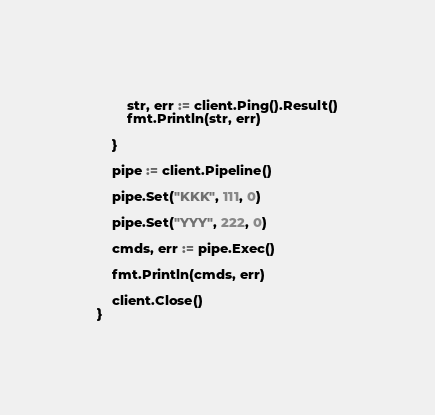Convert code to text. <code><loc_0><loc_0><loc_500><loc_500><_Go_>
		str, err := client.Ping().Result()
		fmt.Println(str, err)

	}

	pipe := client.Pipeline()

	pipe.Set("KKK", 111, 0)

	pipe.Set("YYY", 222, 0)

	cmds, err := pipe.Exec()

	fmt.Println(cmds, err)

	client.Close()
}
</code> 